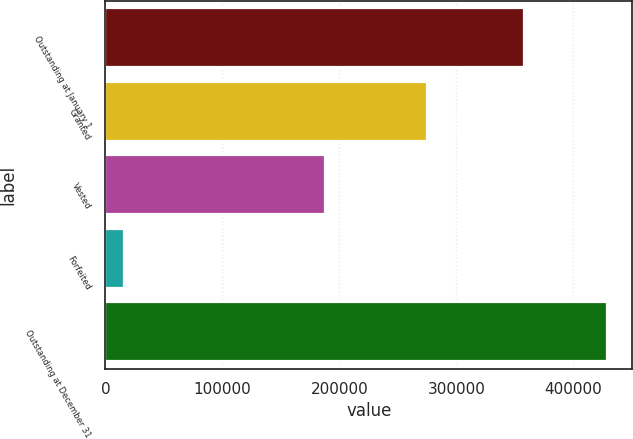Convert chart to OTSL. <chart><loc_0><loc_0><loc_500><loc_500><bar_chart><fcel>Outstanding at January 1<fcel>Granted<fcel>Vested<fcel>Forfeited<fcel>Outstanding at December 31<nl><fcel>357750<fcel>274715<fcel>187397<fcel>16027<fcel>429041<nl></chart> 